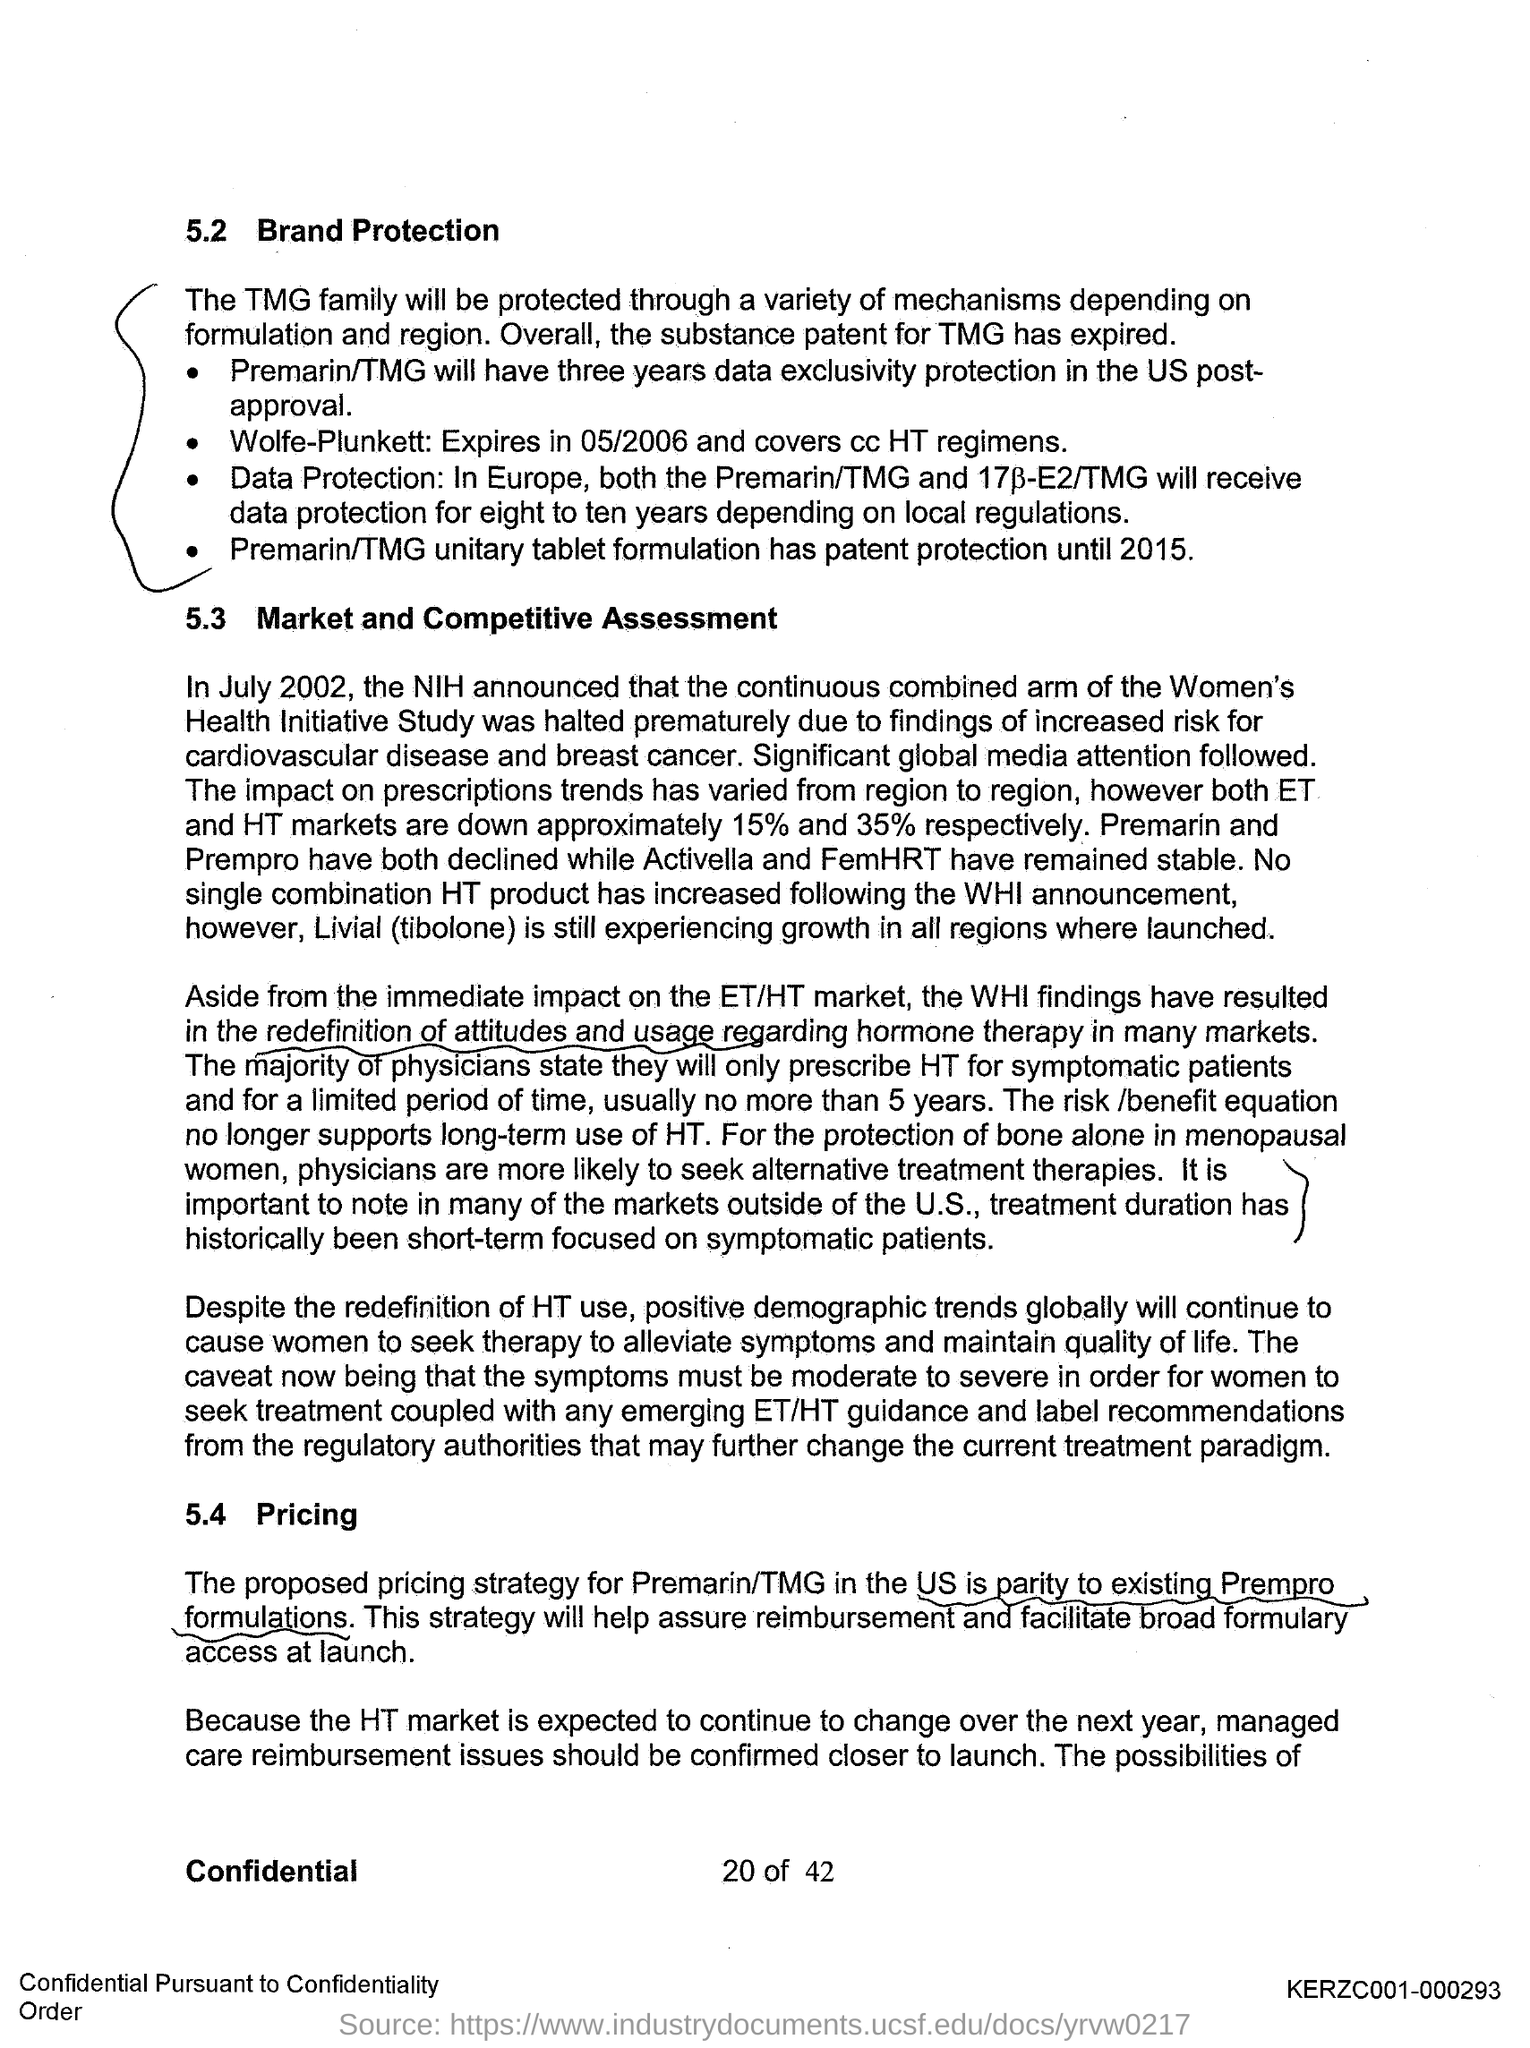What is the first title in the document?
Keep it short and to the point. Brand Protection. What is the second title in this document?
Offer a very short reply. Market and competitive Assessment. 